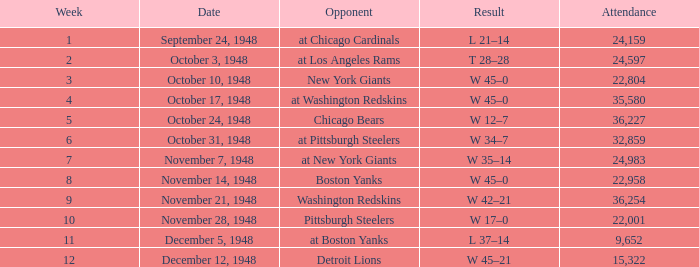What is the minimum week number when the attendance exceeds 22,958 and the opposing team is the chicago cardinals? 1.0. 